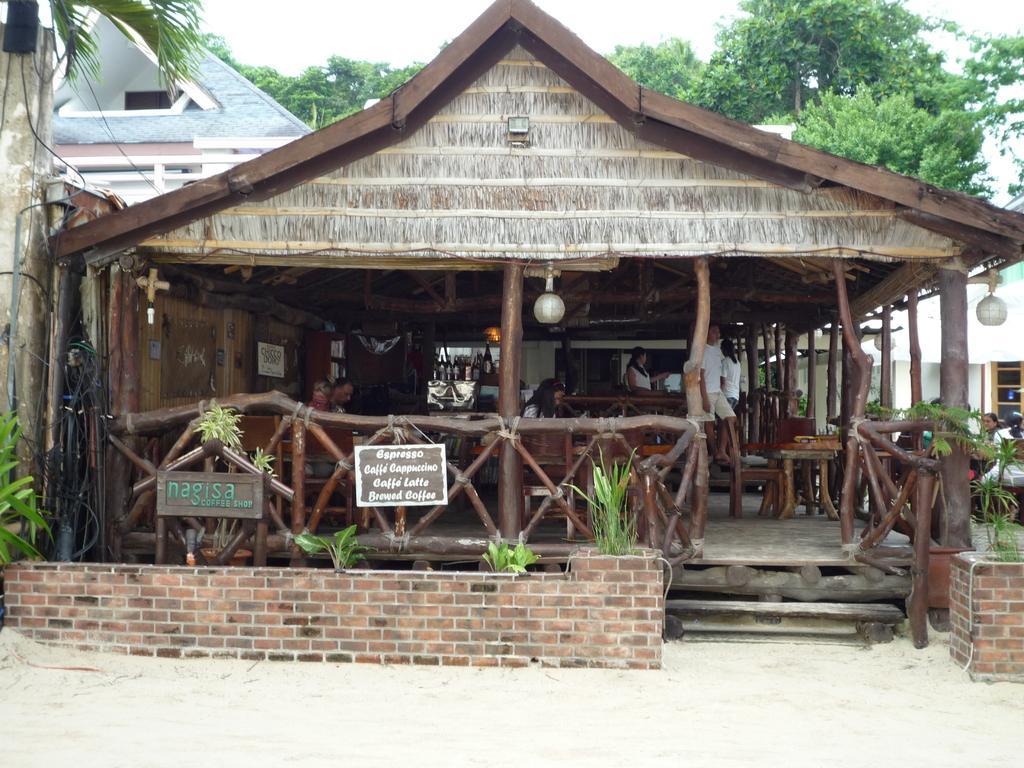How would you summarize this image in a sentence or two? In this image I can see a house and under the house I can see table and chairs and persons , in front of the house I can see plants and the wall ,at the top I can see trees and the sky and building. 